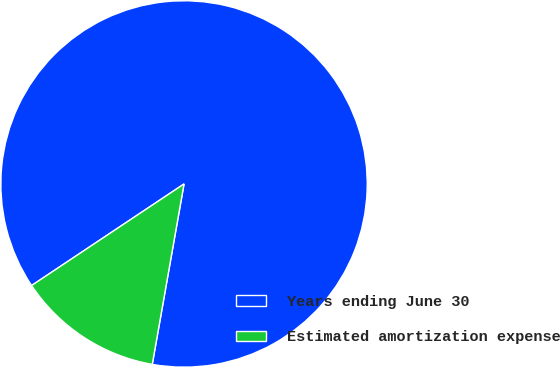Convert chart to OTSL. <chart><loc_0><loc_0><loc_500><loc_500><pie_chart><fcel>Years ending June 30<fcel>Estimated amortization expense<nl><fcel>87.13%<fcel>12.87%<nl></chart> 